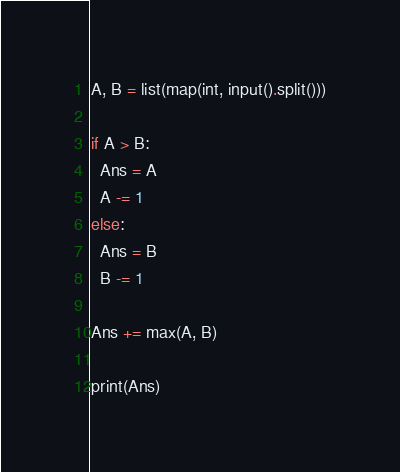<code> <loc_0><loc_0><loc_500><loc_500><_Python_>A, B = list(map(int, input().split()))

if A > B:
  Ans = A
  A -= 1
else:
  Ans = B
  B -= 1

Ans += max(A, B)

print(Ans)</code> 